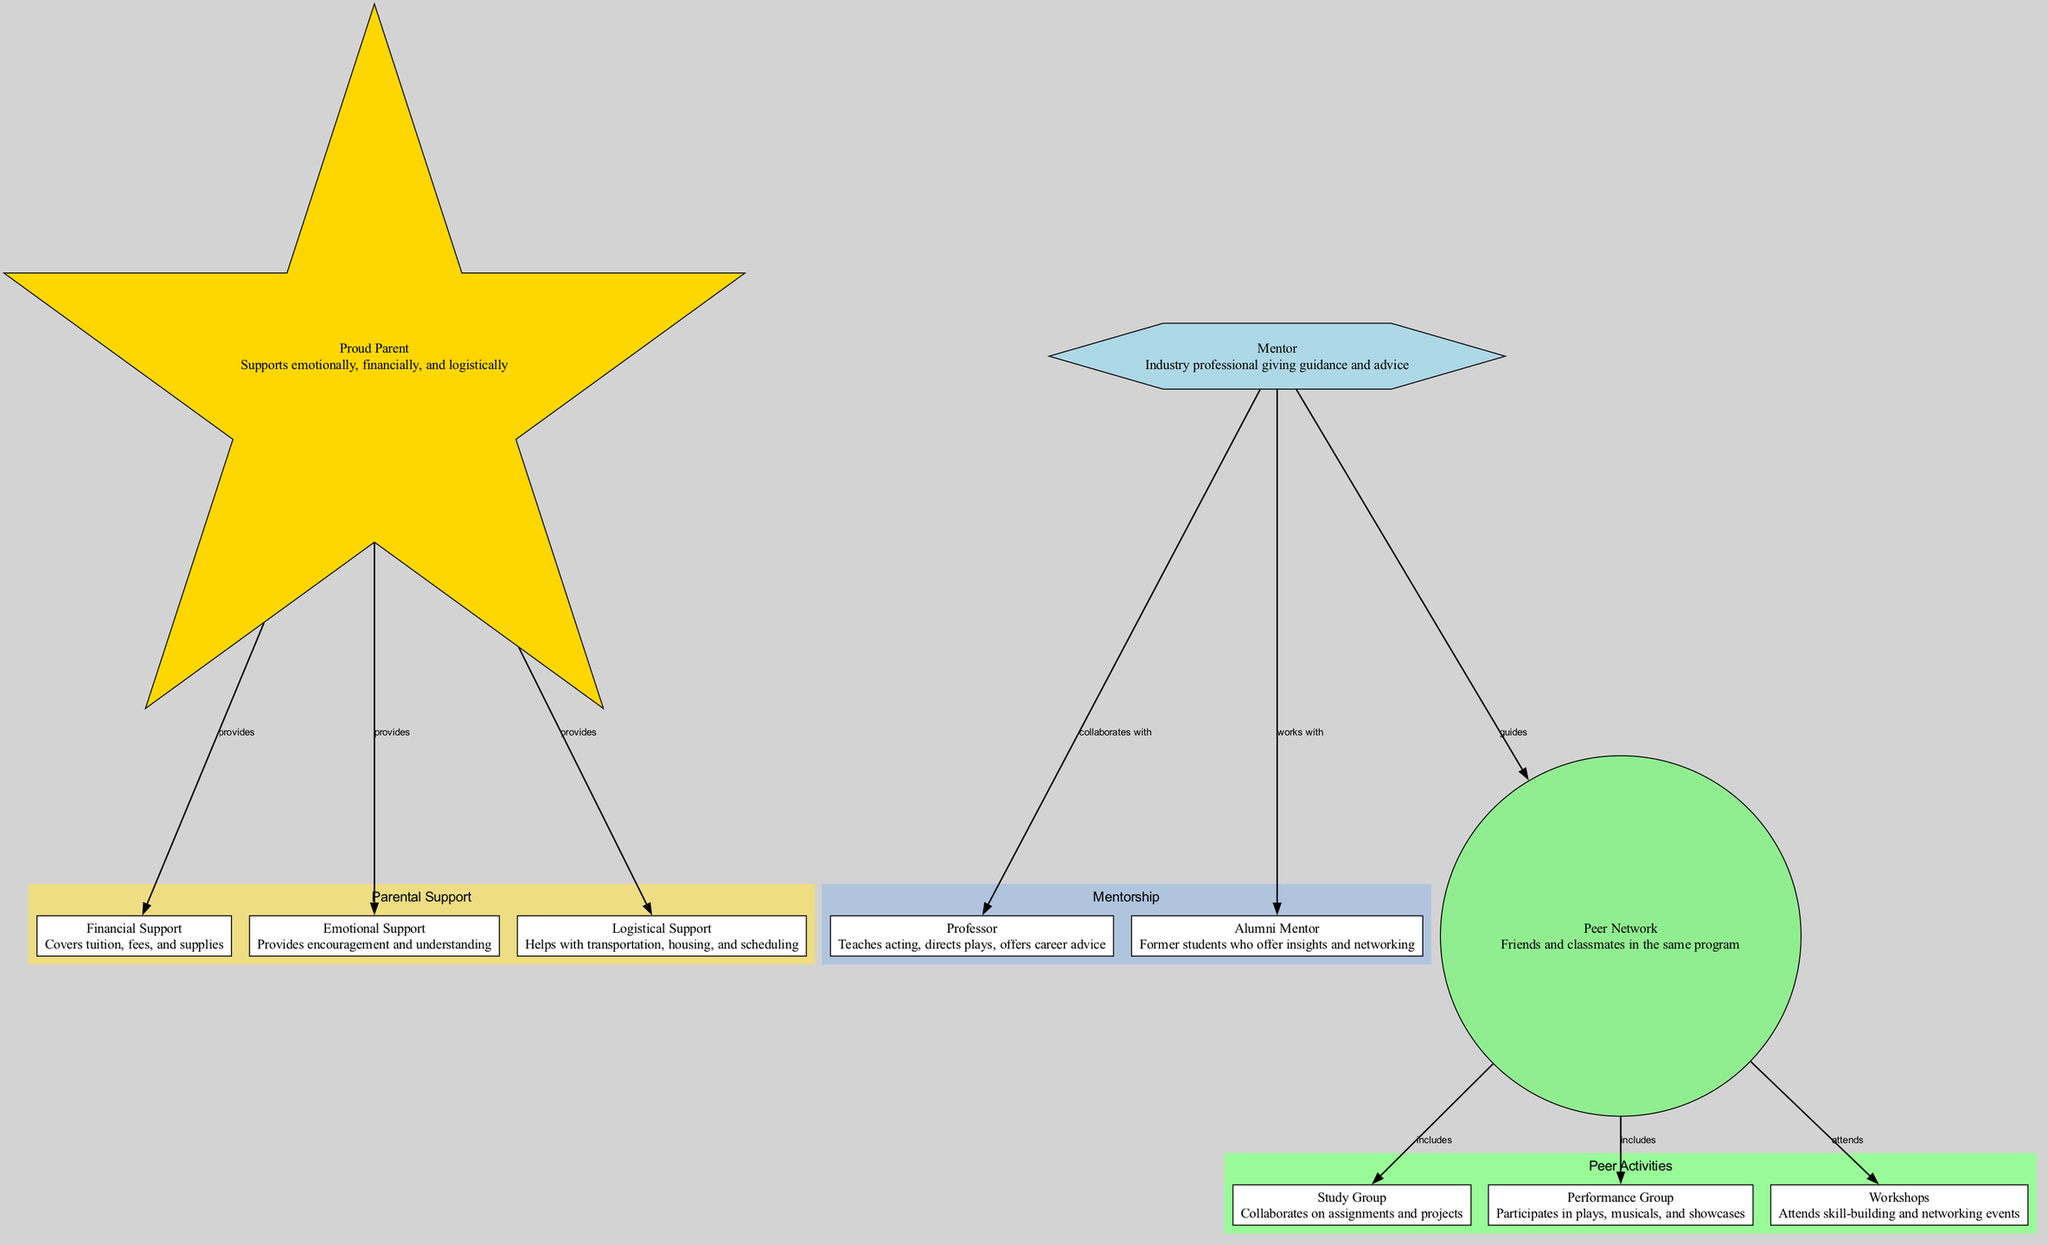What are the three types of support provided by the Proud Parent? The diagram lists three specific types of support associated with the Proud Parent: Financial Support, Emotional Support, and Logistical Support. Each of these supports is connected to the Proud Parent, highlighting their roles in the support system.
Answer: Financial Support, Emotional Support, Logistical Support Who collaborates with the Mentor? The diagram shows that the Mentor collaborates with the Professor. This connection indicates a direct relationship where both are working together within the mentorship framework provided for theatre students.
Answer: Professor How many nodes are in the diagram? By counting all the distinct entities in the diagram, there are a total of 11 nodes representing different roles and types of support in the theatre student support system.
Answer: 11 What does the Peer Network include? The Peer Network includes Study Group, Performance Group, and Workshops. These connections demonstrate the types of collaborative and communal activities available for students within the program.
Answer: Study Group, Performance Group, Workshops Which type of support provides encouragement and understanding? From the descriptions in the diagram, the Emotional Support is explicitly stated to provide encouragement and understanding. This highlights its role in fostering a supportive environment for the theatre student.
Answer: Emotional Support How does the Mentor guide the Peer Network? The diagram illustrates that the Mentor guides the Peer Network. This indicates the Mentor's role in influencing and providing direction to students interacting within the Peer Network, emphasizing mentorship's importance.
Answer: guides What hierarchical relationship exists between the Proud Parent and Financial Support? The diagram indicates a direct support relationship where the Proud Parent provides Financial Support. This connection showcases the flow of assistance from the parent to the financial aspect required in a student's journey.
Answer: provides Which groups attend Workshops? The diagram indicates that the Peer Network attends Workshops. This association highlights that members of the Peer Network are involved in skill-building and networking through these events.
Answer: Peer Network 